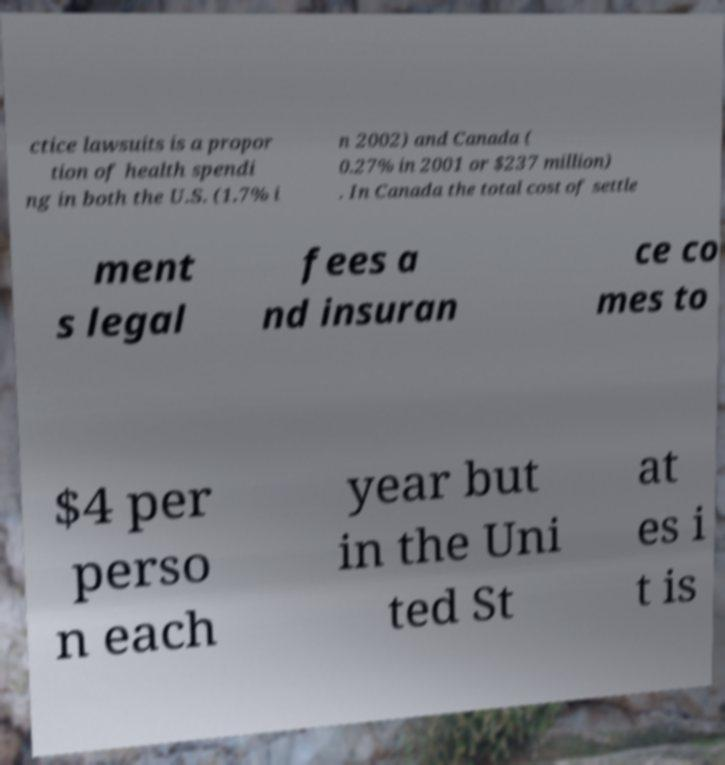Could you extract and type out the text from this image? ctice lawsuits is a propor tion of health spendi ng in both the U.S. (1.7% i n 2002) and Canada ( 0.27% in 2001 or $237 million) . In Canada the total cost of settle ment s legal fees a nd insuran ce co mes to $4 per perso n each year but in the Uni ted St at es i t is 